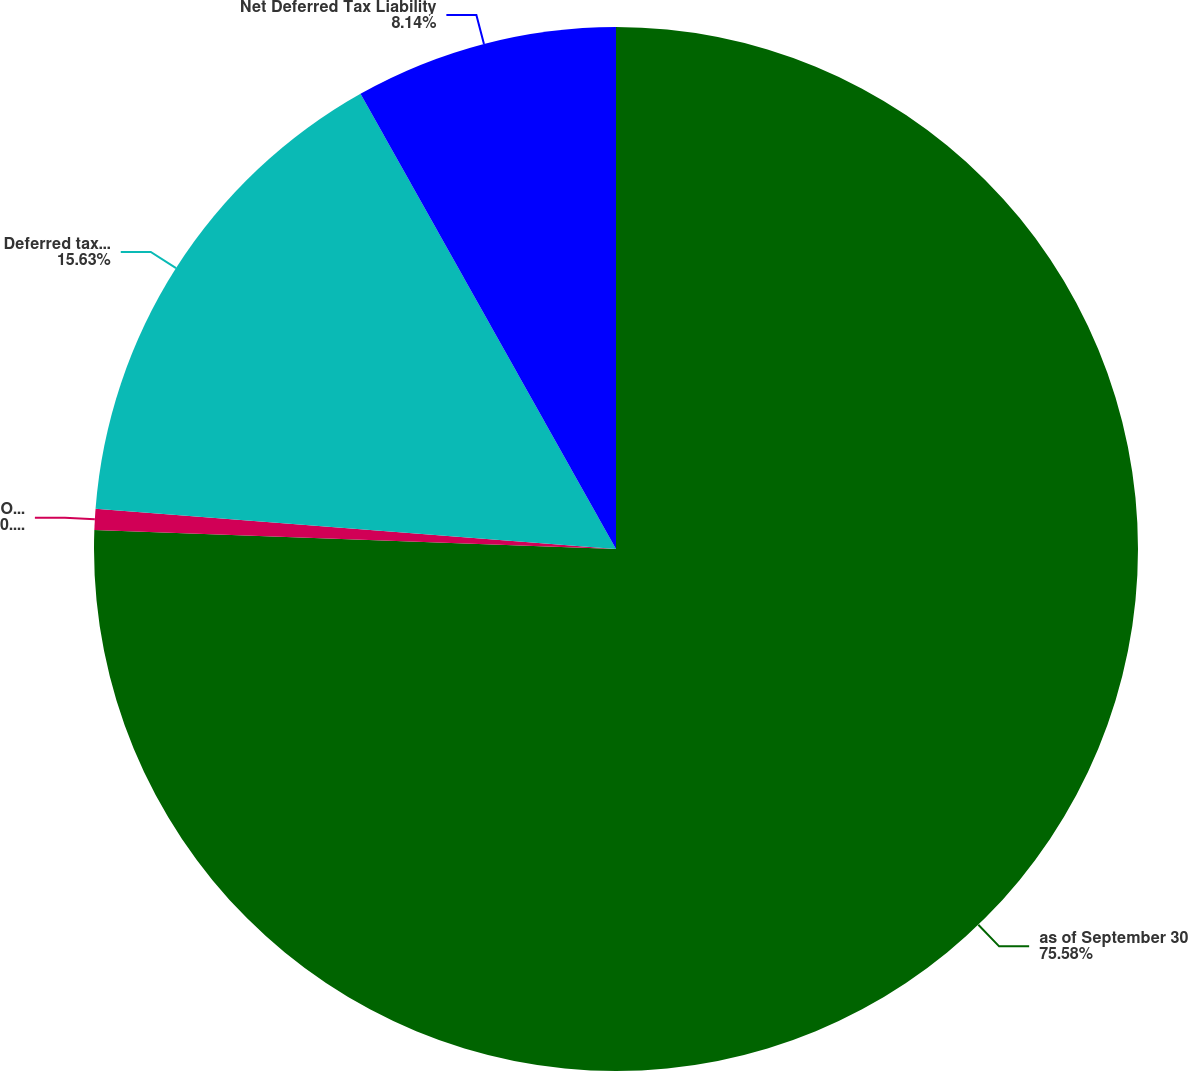Convert chart. <chart><loc_0><loc_0><loc_500><loc_500><pie_chart><fcel>as of September 30<fcel>Other assets<fcel>Deferred tax liabilities<fcel>Net Deferred Tax Liability<nl><fcel>75.58%<fcel>0.65%<fcel>15.63%<fcel>8.14%<nl></chart> 